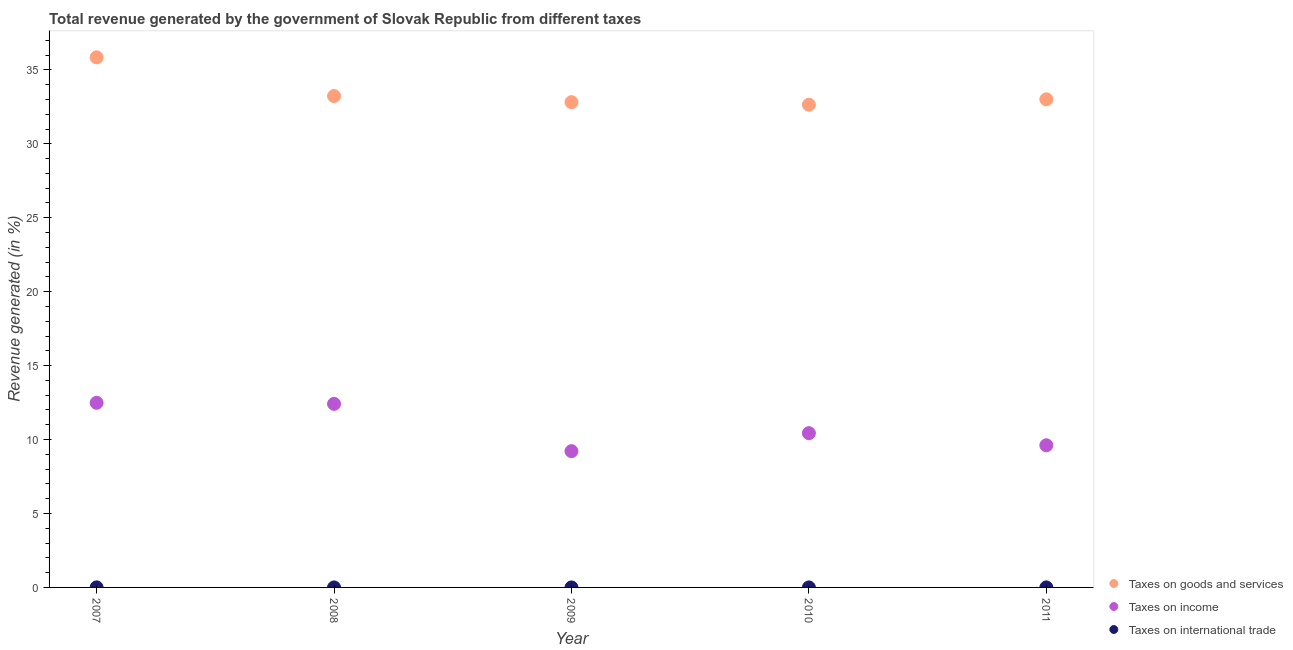How many different coloured dotlines are there?
Provide a succinct answer. 3. Is the number of dotlines equal to the number of legend labels?
Your answer should be compact. Yes. What is the percentage of revenue generated by taxes on income in 2010?
Make the answer very short. 10.43. Across all years, what is the maximum percentage of revenue generated by tax on international trade?
Your response must be concise. 0. Across all years, what is the minimum percentage of revenue generated by taxes on goods and services?
Your response must be concise. 32.65. In which year was the percentage of revenue generated by taxes on goods and services maximum?
Your answer should be very brief. 2007. In which year was the percentage of revenue generated by taxes on income minimum?
Provide a succinct answer. 2009. What is the total percentage of revenue generated by taxes on goods and services in the graph?
Your answer should be very brief. 167.55. What is the difference between the percentage of revenue generated by taxes on goods and services in 2008 and that in 2009?
Make the answer very short. 0.41. What is the difference between the percentage of revenue generated by tax on international trade in 2010 and the percentage of revenue generated by taxes on goods and services in 2009?
Give a very brief answer. -32.82. What is the average percentage of revenue generated by taxes on income per year?
Your response must be concise. 10.83. In the year 2007, what is the difference between the percentage of revenue generated by taxes on income and percentage of revenue generated by taxes on goods and services?
Give a very brief answer. -23.36. In how many years, is the percentage of revenue generated by taxes on income greater than 6 %?
Your answer should be compact. 5. What is the ratio of the percentage of revenue generated by tax on international trade in 2008 to that in 2010?
Your answer should be very brief. 0.52. Is the percentage of revenue generated by taxes on goods and services in 2007 less than that in 2010?
Your response must be concise. No. What is the difference between the highest and the second highest percentage of revenue generated by taxes on income?
Give a very brief answer. 0.07. What is the difference between the highest and the lowest percentage of revenue generated by taxes on goods and services?
Offer a very short reply. 3.2. In how many years, is the percentage of revenue generated by taxes on goods and services greater than the average percentage of revenue generated by taxes on goods and services taken over all years?
Your answer should be very brief. 1. Is it the case that in every year, the sum of the percentage of revenue generated by taxes on goods and services and percentage of revenue generated by taxes on income is greater than the percentage of revenue generated by tax on international trade?
Provide a succinct answer. Yes. Is the percentage of revenue generated by taxes on goods and services strictly greater than the percentage of revenue generated by taxes on income over the years?
Your answer should be compact. Yes. Are the values on the major ticks of Y-axis written in scientific E-notation?
Ensure brevity in your answer.  No. Does the graph contain any zero values?
Offer a very short reply. No. Where does the legend appear in the graph?
Make the answer very short. Bottom right. How many legend labels are there?
Provide a succinct answer. 3. How are the legend labels stacked?
Your answer should be very brief. Vertical. What is the title of the graph?
Your answer should be very brief. Total revenue generated by the government of Slovak Republic from different taxes. What is the label or title of the Y-axis?
Your answer should be very brief. Revenue generated (in %). What is the Revenue generated (in %) in Taxes on goods and services in 2007?
Your answer should be very brief. 35.85. What is the Revenue generated (in %) in Taxes on income in 2007?
Make the answer very short. 12.49. What is the Revenue generated (in %) in Taxes on international trade in 2007?
Ensure brevity in your answer.  0. What is the Revenue generated (in %) of Taxes on goods and services in 2008?
Your answer should be very brief. 33.23. What is the Revenue generated (in %) of Taxes on income in 2008?
Provide a succinct answer. 12.41. What is the Revenue generated (in %) of Taxes on international trade in 2008?
Keep it short and to the point. 0. What is the Revenue generated (in %) of Taxes on goods and services in 2009?
Your response must be concise. 32.82. What is the Revenue generated (in %) of Taxes on income in 2009?
Keep it short and to the point. 9.22. What is the Revenue generated (in %) in Taxes on international trade in 2009?
Make the answer very short. 0. What is the Revenue generated (in %) of Taxes on goods and services in 2010?
Provide a succinct answer. 32.65. What is the Revenue generated (in %) in Taxes on income in 2010?
Give a very brief answer. 10.43. What is the Revenue generated (in %) of Taxes on international trade in 2010?
Ensure brevity in your answer.  0. What is the Revenue generated (in %) of Taxes on goods and services in 2011?
Offer a terse response. 33.01. What is the Revenue generated (in %) in Taxes on income in 2011?
Offer a terse response. 9.61. What is the Revenue generated (in %) in Taxes on international trade in 2011?
Your answer should be very brief. 0. Across all years, what is the maximum Revenue generated (in %) of Taxes on goods and services?
Your response must be concise. 35.85. Across all years, what is the maximum Revenue generated (in %) of Taxes on income?
Offer a very short reply. 12.49. Across all years, what is the maximum Revenue generated (in %) in Taxes on international trade?
Keep it short and to the point. 0. Across all years, what is the minimum Revenue generated (in %) of Taxes on goods and services?
Give a very brief answer. 32.65. Across all years, what is the minimum Revenue generated (in %) in Taxes on income?
Your answer should be compact. 9.22. Across all years, what is the minimum Revenue generated (in %) of Taxes on international trade?
Provide a succinct answer. 0. What is the total Revenue generated (in %) of Taxes on goods and services in the graph?
Make the answer very short. 167.55. What is the total Revenue generated (in %) in Taxes on income in the graph?
Your answer should be very brief. 54.16. What is the total Revenue generated (in %) in Taxes on international trade in the graph?
Keep it short and to the point. 0.01. What is the difference between the Revenue generated (in %) in Taxes on goods and services in 2007 and that in 2008?
Provide a succinct answer. 2.62. What is the difference between the Revenue generated (in %) in Taxes on income in 2007 and that in 2008?
Provide a short and direct response. 0.07. What is the difference between the Revenue generated (in %) in Taxes on international trade in 2007 and that in 2008?
Offer a very short reply. 0. What is the difference between the Revenue generated (in %) in Taxes on goods and services in 2007 and that in 2009?
Ensure brevity in your answer.  3.03. What is the difference between the Revenue generated (in %) of Taxes on income in 2007 and that in 2009?
Offer a very short reply. 3.27. What is the difference between the Revenue generated (in %) in Taxes on international trade in 2007 and that in 2009?
Provide a succinct answer. 0. What is the difference between the Revenue generated (in %) in Taxes on goods and services in 2007 and that in 2010?
Offer a terse response. 3.2. What is the difference between the Revenue generated (in %) in Taxes on income in 2007 and that in 2010?
Provide a succinct answer. 2.05. What is the difference between the Revenue generated (in %) of Taxes on international trade in 2007 and that in 2010?
Provide a succinct answer. 0. What is the difference between the Revenue generated (in %) in Taxes on goods and services in 2007 and that in 2011?
Keep it short and to the point. 2.84. What is the difference between the Revenue generated (in %) in Taxes on income in 2007 and that in 2011?
Your answer should be very brief. 2.87. What is the difference between the Revenue generated (in %) in Taxes on international trade in 2007 and that in 2011?
Provide a short and direct response. 0. What is the difference between the Revenue generated (in %) of Taxes on goods and services in 2008 and that in 2009?
Your answer should be very brief. 0.41. What is the difference between the Revenue generated (in %) of Taxes on income in 2008 and that in 2009?
Keep it short and to the point. 3.2. What is the difference between the Revenue generated (in %) in Taxes on international trade in 2008 and that in 2009?
Ensure brevity in your answer.  -0. What is the difference between the Revenue generated (in %) of Taxes on goods and services in 2008 and that in 2010?
Provide a short and direct response. 0.58. What is the difference between the Revenue generated (in %) in Taxes on income in 2008 and that in 2010?
Provide a succinct answer. 1.98. What is the difference between the Revenue generated (in %) of Taxes on international trade in 2008 and that in 2010?
Your response must be concise. -0. What is the difference between the Revenue generated (in %) in Taxes on goods and services in 2008 and that in 2011?
Give a very brief answer. 0.22. What is the difference between the Revenue generated (in %) of Taxes on income in 2008 and that in 2011?
Make the answer very short. 2.8. What is the difference between the Revenue generated (in %) in Taxes on international trade in 2008 and that in 2011?
Your answer should be very brief. -0. What is the difference between the Revenue generated (in %) of Taxes on goods and services in 2009 and that in 2010?
Ensure brevity in your answer.  0.17. What is the difference between the Revenue generated (in %) in Taxes on income in 2009 and that in 2010?
Your answer should be compact. -1.22. What is the difference between the Revenue generated (in %) of Taxes on international trade in 2009 and that in 2010?
Provide a succinct answer. -0. What is the difference between the Revenue generated (in %) in Taxes on goods and services in 2009 and that in 2011?
Ensure brevity in your answer.  -0.19. What is the difference between the Revenue generated (in %) in Taxes on income in 2009 and that in 2011?
Offer a very short reply. -0.4. What is the difference between the Revenue generated (in %) of Taxes on international trade in 2009 and that in 2011?
Offer a very short reply. -0. What is the difference between the Revenue generated (in %) in Taxes on goods and services in 2010 and that in 2011?
Ensure brevity in your answer.  -0.36. What is the difference between the Revenue generated (in %) of Taxes on income in 2010 and that in 2011?
Provide a short and direct response. 0.82. What is the difference between the Revenue generated (in %) in Taxes on international trade in 2010 and that in 2011?
Make the answer very short. -0. What is the difference between the Revenue generated (in %) in Taxes on goods and services in 2007 and the Revenue generated (in %) in Taxes on income in 2008?
Ensure brevity in your answer.  23.43. What is the difference between the Revenue generated (in %) of Taxes on goods and services in 2007 and the Revenue generated (in %) of Taxes on international trade in 2008?
Your response must be concise. 35.85. What is the difference between the Revenue generated (in %) of Taxes on income in 2007 and the Revenue generated (in %) of Taxes on international trade in 2008?
Provide a succinct answer. 12.48. What is the difference between the Revenue generated (in %) of Taxes on goods and services in 2007 and the Revenue generated (in %) of Taxes on income in 2009?
Make the answer very short. 26.63. What is the difference between the Revenue generated (in %) in Taxes on goods and services in 2007 and the Revenue generated (in %) in Taxes on international trade in 2009?
Your response must be concise. 35.85. What is the difference between the Revenue generated (in %) in Taxes on income in 2007 and the Revenue generated (in %) in Taxes on international trade in 2009?
Provide a short and direct response. 12.48. What is the difference between the Revenue generated (in %) of Taxes on goods and services in 2007 and the Revenue generated (in %) of Taxes on income in 2010?
Offer a terse response. 25.42. What is the difference between the Revenue generated (in %) of Taxes on goods and services in 2007 and the Revenue generated (in %) of Taxes on international trade in 2010?
Give a very brief answer. 35.85. What is the difference between the Revenue generated (in %) in Taxes on income in 2007 and the Revenue generated (in %) in Taxes on international trade in 2010?
Provide a short and direct response. 12.48. What is the difference between the Revenue generated (in %) in Taxes on goods and services in 2007 and the Revenue generated (in %) in Taxes on income in 2011?
Make the answer very short. 26.23. What is the difference between the Revenue generated (in %) in Taxes on goods and services in 2007 and the Revenue generated (in %) in Taxes on international trade in 2011?
Offer a very short reply. 35.85. What is the difference between the Revenue generated (in %) in Taxes on income in 2007 and the Revenue generated (in %) in Taxes on international trade in 2011?
Provide a succinct answer. 12.48. What is the difference between the Revenue generated (in %) in Taxes on goods and services in 2008 and the Revenue generated (in %) in Taxes on income in 2009?
Provide a short and direct response. 24.01. What is the difference between the Revenue generated (in %) of Taxes on goods and services in 2008 and the Revenue generated (in %) of Taxes on international trade in 2009?
Provide a succinct answer. 33.23. What is the difference between the Revenue generated (in %) in Taxes on income in 2008 and the Revenue generated (in %) in Taxes on international trade in 2009?
Offer a very short reply. 12.41. What is the difference between the Revenue generated (in %) in Taxes on goods and services in 2008 and the Revenue generated (in %) in Taxes on income in 2010?
Your answer should be compact. 22.8. What is the difference between the Revenue generated (in %) of Taxes on goods and services in 2008 and the Revenue generated (in %) of Taxes on international trade in 2010?
Give a very brief answer. 33.23. What is the difference between the Revenue generated (in %) of Taxes on income in 2008 and the Revenue generated (in %) of Taxes on international trade in 2010?
Provide a short and direct response. 12.41. What is the difference between the Revenue generated (in %) of Taxes on goods and services in 2008 and the Revenue generated (in %) of Taxes on income in 2011?
Your answer should be very brief. 23.62. What is the difference between the Revenue generated (in %) in Taxes on goods and services in 2008 and the Revenue generated (in %) in Taxes on international trade in 2011?
Provide a succinct answer. 33.23. What is the difference between the Revenue generated (in %) in Taxes on income in 2008 and the Revenue generated (in %) in Taxes on international trade in 2011?
Your answer should be very brief. 12.41. What is the difference between the Revenue generated (in %) of Taxes on goods and services in 2009 and the Revenue generated (in %) of Taxes on income in 2010?
Ensure brevity in your answer.  22.39. What is the difference between the Revenue generated (in %) of Taxes on goods and services in 2009 and the Revenue generated (in %) of Taxes on international trade in 2010?
Make the answer very short. 32.82. What is the difference between the Revenue generated (in %) of Taxes on income in 2009 and the Revenue generated (in %) of Taxes on international trade in 2010?
Keep it short and to the point. 9.22. What is the difference between the Revenue generated (in %) of Taxes on goods and services in 2009 and the Revenue generated (in %) of Taxes on income in 2011?
Your answer should be very brief. 23.2. What is the difference between the Revenue generated (in %) in Taxes on goods and services in 2009 and the Revenue generated (in %) in Taxes on international trade in 2011?
Provide a succinct answer. 32.82. What is the difference between the Revenue generated (in %) of Taxes on income in 2009 and the Revenue generated (in %) of Taxes on international trade in 2011?
Give a very brief answer. 9.22. What is the difference between the Revenue generated (in %) of Taxes on goods and services in 2010 and the Revenue generated (in %) of Taxes on income in 2011?
Make the answer very short. 23.03. What is the difference between the Revenue generated (in %) in Taxes on goods and services in 2010 and the Revenue generated (in %) in Taxes on international trade in 2011?
Make the answer very short. 32.65. What is the difference between the Revenue generated (in %) in Taxes on income in 2010 and the Revenue generated (in %) in Taxes on international trade in 2011?
Your answer should be compact. 10.43. What is the average Revenue generated (in %) of Taxes on goods and services per year?
Provide a succinct answer. 33.51. What is the average Revenue generated (in %) in Taxes on income per year?
Offer a terse response. 10.83. What is the average Revenue generated (in %) in Taxes on international trade per year?
Your answer should be very brief. 0. In the year 2007, what is the difference between the Revenue generated (in %) in Taxes on goods and services and Revenue generated (in %) in Taxes on income?
Your answer should be very brief. 23.36. In the year 2007, what is the difference between the Revenue generated (in %) in Taxes on goods and services and Revenue generated (in %) in Taxes on international trade?
Provide a succinct answer. 35.84. In the year 2007, what is the difference between the Revenue generated (in %) of Taxes on income and Revenue generated (in %) of Taxes on international trade?
Offer a very short reply. 12.48. In the year 2008, what is the difference between the Revenue generated (in %) in Taxes on goods and services and Revenue generated (in %) in Taxes on income?
Offer a terse response. 20.82. In the year 2008, what is the difference between the Revenue generated (in %) in Taxes on goods and services and Revenue generated (in %) in Taxes on international trade?
Provide a short and direct response. 33.23. In the year 2008, what is the difference between the Revenue generated (in %) of Taxes on income and Revenue generated (in %) of Taxes on international trade?
Keep it short and to the point. 12.41. In the year 2009, what is the difference between the Revenue generated (in %) of Taxes on goods and services and Revenue generated (in %) of Taxes on income?
Offer a terse response. 23.6. In the year 2009, what is the difference between the Revenue generated (in %) of Taxes on goods and services and Revenue generated (in %) of Taxes on international trade?
Provide a succinct answer. 32.82. In the year 2009, what is the difference between the Revenue generated (in %) of Taxes on income and Revenue generated (in %) of Taxes on international trade?
Your response must be concise. 9.22. In the year 2010, what is the difference between the Revenue generated (in %) in Taxes on goods and services and Revenue generated (in %) in Taxes on income?
Keep it short and to the point. 22.21. In the year 2010, what is the difference between the Revenue generated (in %) of Taxes on goods and services and Revenue generated (in %) of Taxes on international trade?
Your response must be concise. 32.65. In the year 2010, what is the difference between the Revenue generated (in %) in Taxes on income and Revenue generated (in %) in Taxes on international trade?
Keep it short and to the point. 10.43. In the year 2011, what is the difference between the Revenue generated (in %) of Taxes on goods and services and Revenue generated (in %) of Taxes on income?
Offer a terse response. 23.4. In the year 2011, what is the difference between the Revenue generated (in %) of Taxes on goods and services and Revenue generated (in %) of Taxes on international trade?
Offer a terse response. 33.01. In the year 2011, what is the difference between the Revenue generated (in %) in Taxes on income and Revenue generated (in %) in Taxes on international trade?
Your answer should be compact. 9.61. What is the ratio of the Revenue generated (in %) of Taxes on goods and services in 2007 to that in 2008?
Provide a succinct answer. 1.08. What is the ratio of the Revenue generated (in %) of Taxes on income in 2007 to that in 2008?
Provide a succinct answer. 1.01. What is the ratio of the Revenue generated (in %) of Taxes on international trade in 2007 to that in 2008?
Keep it short and to the point. 27.08. What is the ratio of the Revenue generated (in %) in Taxes on goods and services in 2007 to that in 2009?
Keep it short and to the point. 1.09. What is the ratio of the Revenue generated (in %) of Taxes on income in 2007 to that in 2009?
Your response must be concise. 1.35. What is the ratio of the Revenue generated (in %) in Taxes on international trade in 2007 to that in 2009?
Offer a very short reply. 26.33. What is the ratio of the Revenue generated (in %) of Taxes on goods and services in 2007 to that in 2010?
Offer a terse response. 1.1. What is the ratio of the Revenue generated (in %) in Taxes on income in 2007 to that in 2010?
Your answer should be very brief. 1.2. What is the ratio of the Revenue generated (in %) of Taxes on international trade in 2007 to that in 2010?
Ensure brevity in your answer.  14.14. What is the ratio of the Revenue generated (in %) of Taxes on goods and services in 2007 to that in 2011?
Keep it short and to the point. 1.09. What is the ratio of the Revenue generated (in %) in Taxes on income in 2007 to that in 2011?
Your answer should be very brief. 1.3. What is the ratio of the Revenue generated (in %) in Taxes on international trade in 2007 to that in 2011?
Provide a short and direct response. 9.34. What is the ratio of the Revenue generated (in %) of Taxes on goods and services in 2008 to that in 2009?
Your answer should be compact. 1.01. What is the ratio of the Revenue generated (in %) in Taxes on income in 2008 to that in 2009?
Ensure brevity in your answer.  1.35. What is the ratio of the Revenue generated (in %) of Taxes on international trade in 2008 to that in 2009?
Ensure brevity in your answer.  0.97. What is the ratio of the Revenue generated (in %) in Taxes on goods and services in 2008 to that in 2010?
Keep it short and to the point. 1.02. What is the ratio of the Revenue generated (in %) in Taxes on income in 2008 to that in 2010?
Offer a terse response. 1.19. What is the ratio of the Revenue generated (in %) in Taxes on international trade in 2008 to that in 2010?
Ensure brevity in your answer.  0.52. What is the ratio of the Revenue generated (in %) of Taxes on income in 2008 to that in 2011?
Your response must be concise. 1.29. What is the ratio of the Revenue generated (in %) of Taxes on international trade in 2008 to that in 2011?
Provide a succinct answer. 0.34. What is the ratio of the Revenue generated (in %) of Taxes on income in 2009 to that in 2010?
Provide a succinct answer. 0.88. What is the ratio of the Revenue generated (in %) in Taxes on international trade in 2009 to that in 2010?
Provide a short and direct response. 0.54. What is the ratio of the Revenue generated (in %) of Taxes on goods and services in 2009 to that in 2011?
Give a very brief answer. 0.99. What is the ratio of the Revenue generated (in %) of Taxes on income in 2009 to that in 2011?
Keep it short and to the point. 0.96. What is the ratio of the Revenue generated (in %) in Taxes on international trade in 2009 to that in 2011?
Make the answer very short. 0.35. What is the ratio of the Revenue generated (in %) in Taxes on income in 2010 to that in 2011?
Offer a terse response. 1.09. What is the ratio of the Revenue generated (in %) of Taxes on international trade in 2010 to that in 2011?
Provide a succinct answer. 0.66. What is the difference between the highest and the second highest Revenue generated (in %) of Taxes on goods and services?
Keep it short and to the point. 2.62. What is the difference between the highest and the second highest Revenue generated (in %) in Taxes on income?
Offer a terse response. 0.07. What is the difference between the highest and the second highest Revenue generated (in %) in Taxes on international trade?
Make the answer very short. 0. What is the difference between the highest and the lowest Revenue generated (in %) in Taxes on goods and services?
Offer a terse response. 3.2. What is the difference between the highest and the lowest Revenue generated (in %) of Taxes on income?
Make the answer very short. 3.27. What is the difference between the highest and the lowest Revenue generated (in %) of Taxes on international trade?
Your answer should be very brief. 0. 